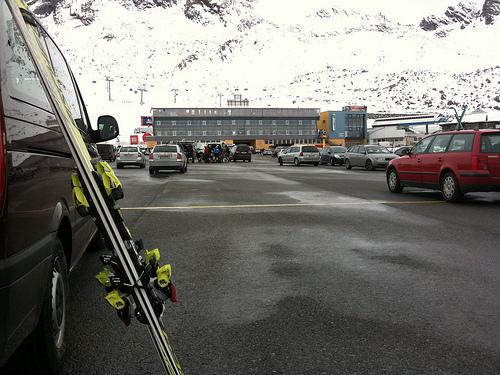Question: what is present?
Choices:
A. Cars.
B. Bicycles.
C. Motorbikes.
D. Golf carts.
Answer with the letter. Answer: A Question: what are they on?
Choices:
A. Bike.
B. Horse.
C. A road.
D. Boat.
Answer with the letter. Answer: C Question: where was this photo taken?
Choices:
A. Mountain.
B. A ski resort.
C. Swimming meet.
D. Dance hall.
Answer with the letter. Answer: B 